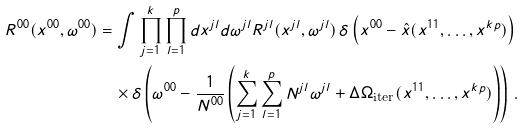<formula> <loc_0><loc_0><loc_500><loc_500>R ^ { 0 0 } ( x ^ { 0 0 } , \omega ^ { 0 0 } ) & = \int \prod _ { j = 1 } ^ { k } \prod _ { l = 1 } ^ { p } d x ^ { j l } d \omega ^ { j l } R ^ { j l } ( x ^ { j l } , \omega ^ { j l } ) \, \delta \left ( x ^ { 0 0 } - \hat { x } ( x ^ { 1 1 } , \dots , x ^ { k p } ) \right ) \\ & \quad \times \delta \left ( \omega ^ { 0 0 } - \frac { 1 } { N ^ { 0 0 } } \left ( \sum _ { j = 1 } ^ { k } \sum _ { l = 1 } ^ { p } N ^ { j l } \omega ^ { j l } + \Delta \Omega _ { \text {iter} } ( x ^ { 1 1 } , \dots , x ^ { k p } ) \right ) \right ) \, .</formula> 